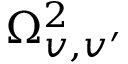<formula> <loc_0><loc_0><loc_500><loc_500>\Omega _ { v , v ^ { \prime } } ^ { 2 }</formula> 